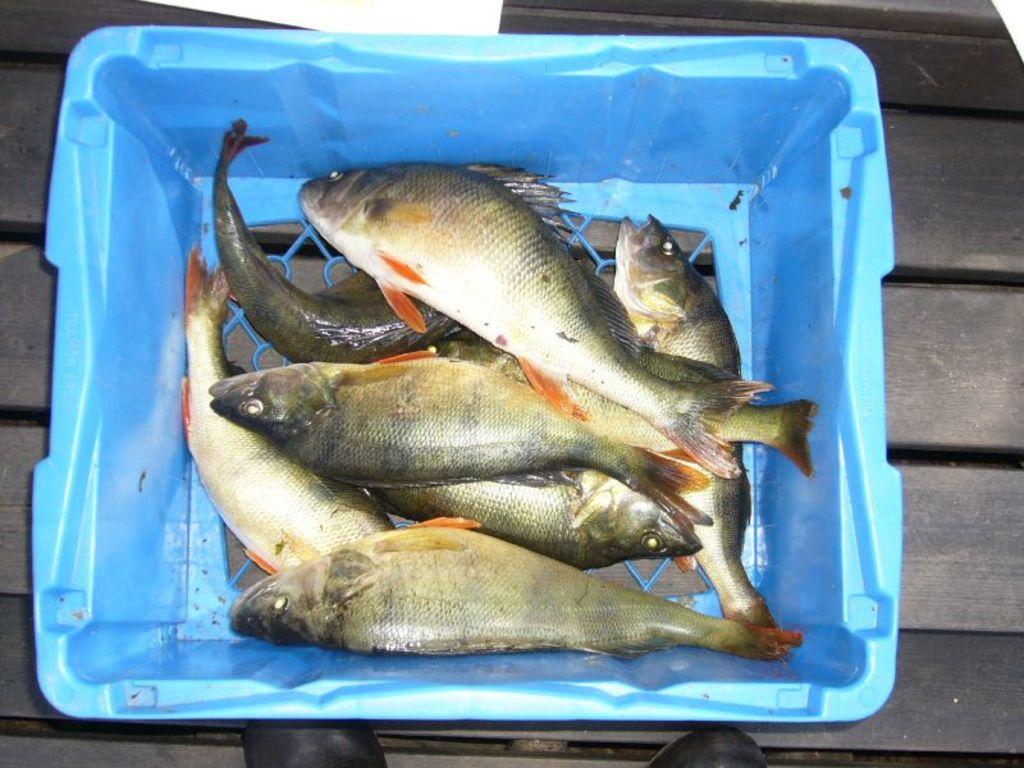What is in the blue basket in the foreground of the image? There are fishes in a blue basket in the foreground of the image. What color is the surface on which the blue basket is placed? The blue basket is placed on a black surface. What other objects can be seen at the bottom side of the image? There are shoes visible at the bottom side of the image. How many cats are playing with the vegetables in the image? There are no cats or vegetables present in the image. 